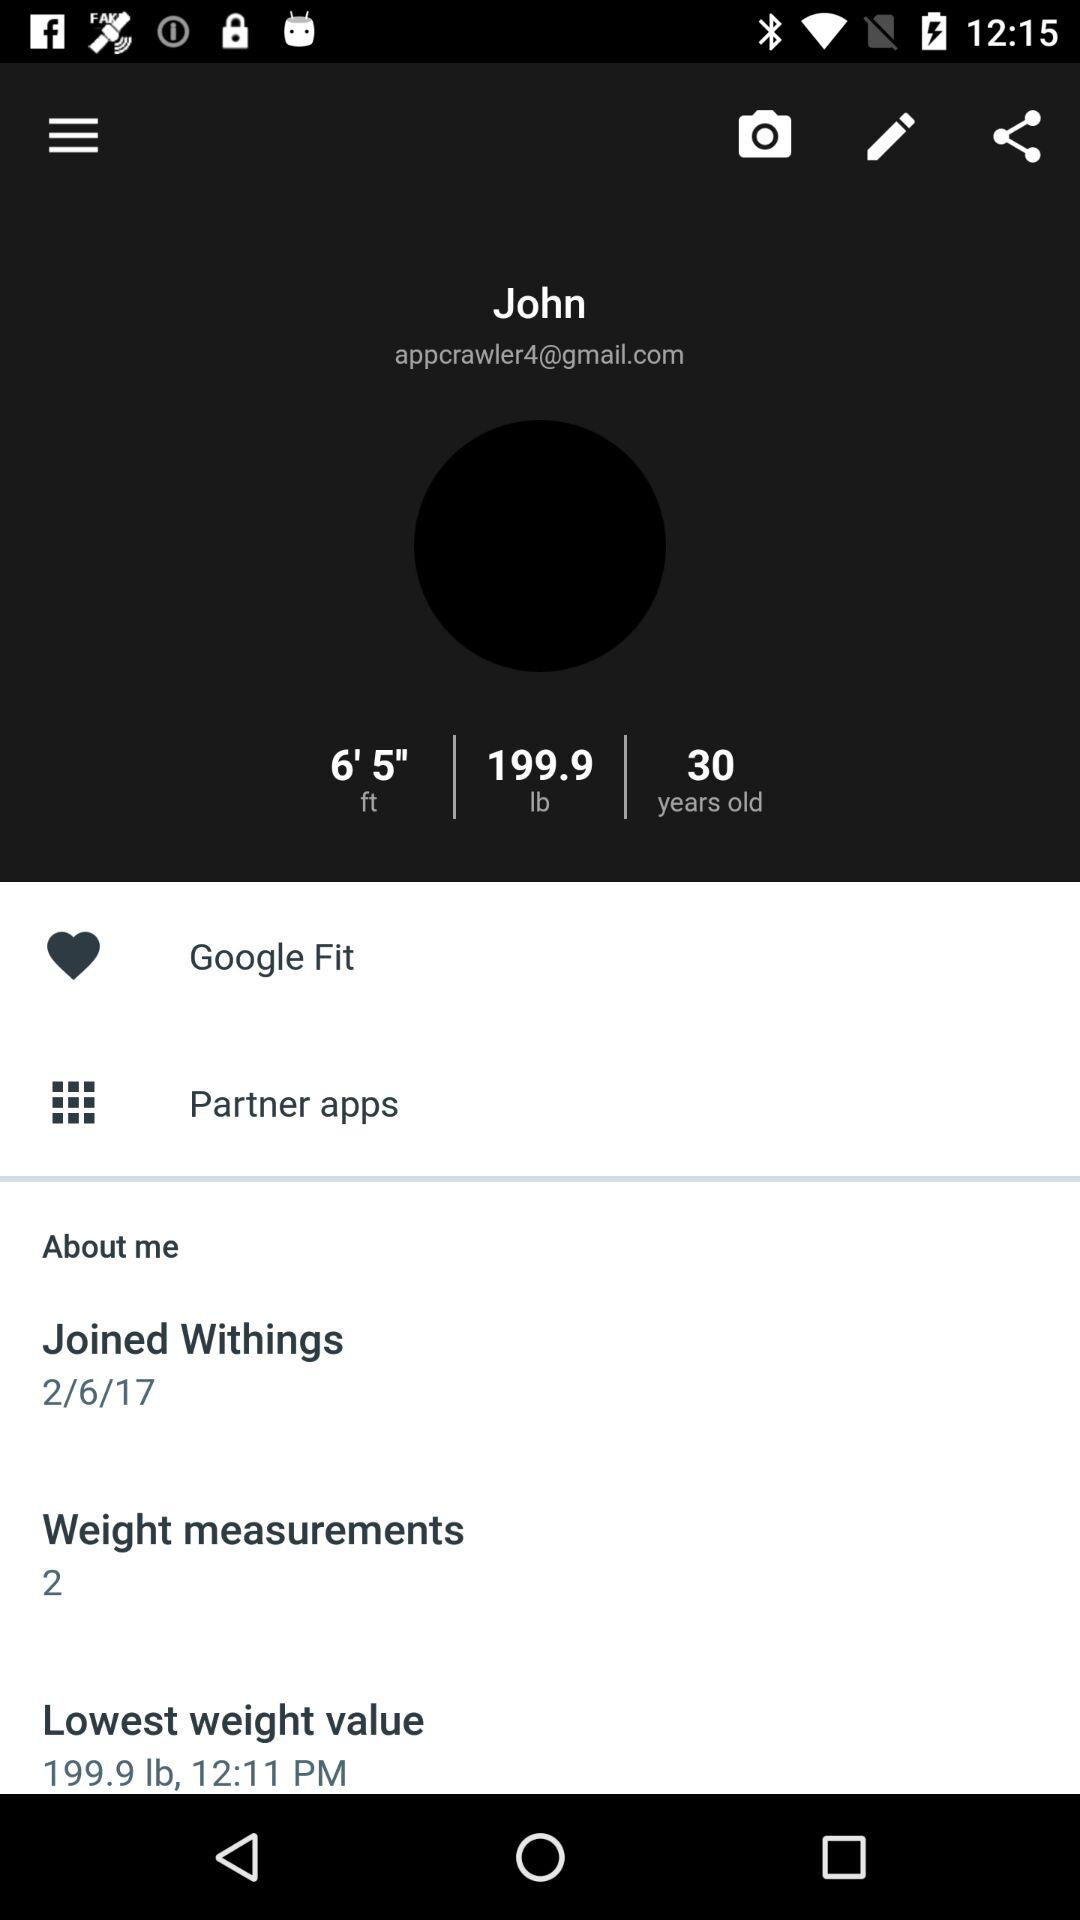What is the email address? The email address is appcrawler4@gmail.com. 